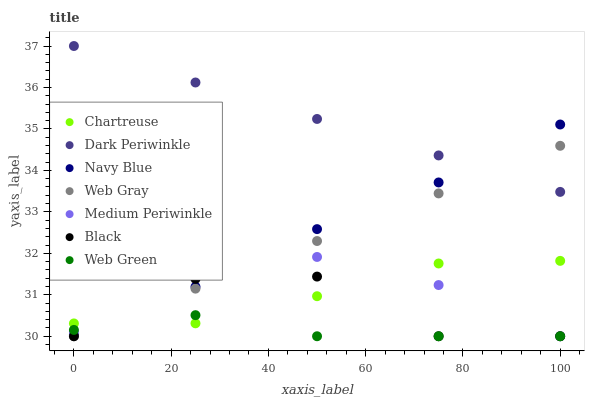Does Web Green have the minimum area under the curve?
Answer yes or no. Yes. Does Dark Periwinkle have the maximum area under the curve?
Answer yes or no. Yes. Does Navy Blue have the minimum area under the curve?
Answer yes or no. No. Does Navy Blue have the maximum area under the curve?
Answer yes or no. No. Is Dark Periwinkle the smoothest?
Answer yes or no. Yes. Is Black the roughest?
Answer yes or no. Yes. Is Navy Blue the smoothest?
Answer yes or no. No. Is Navy Blue the roughest?
Answer yes or no. No. Does Web Gray have the lowest value?
Answer yes or no. Yes. Does Navy Blue have the lowest value?
Answer yes or no. No. Does Dark Periwinkle have the highest value?
Answer yes or no. Yes. Does Navy Blue have the highest value?
Answer yes or no. No. Is Web Gray less than Navy Blue?
Answer yes or no. Yes. Is Dark Periwinkle greater than Chartreuse?
Answer yes or no. Yes. Does Navy Blue intersect Dark Periwinkle?
Answer yes or no. Yes. Is Navy Blue less than Dark Periwinkle?
Answer yes or no. No. Is Navy Blue greater than Dark Periwinkle?
Answer yes or no. No. Does Web Gray intersect Navy Blue?
Answer yes or no. No. 